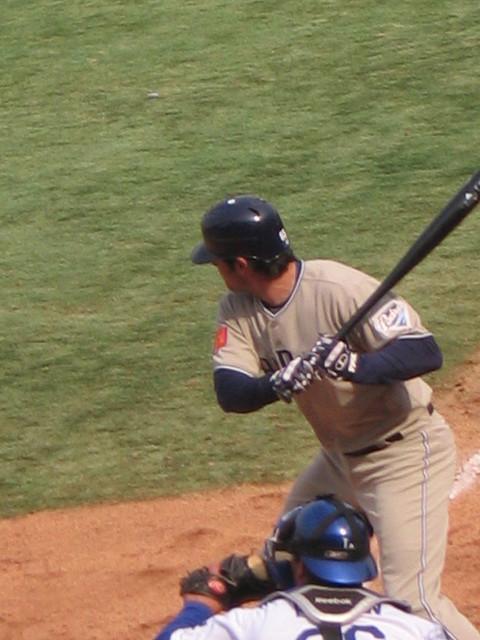How many people are in the photo?
Give a very brief answer. 2. How many pieces of pizza are missing?
Give a very brief answer. 0. 